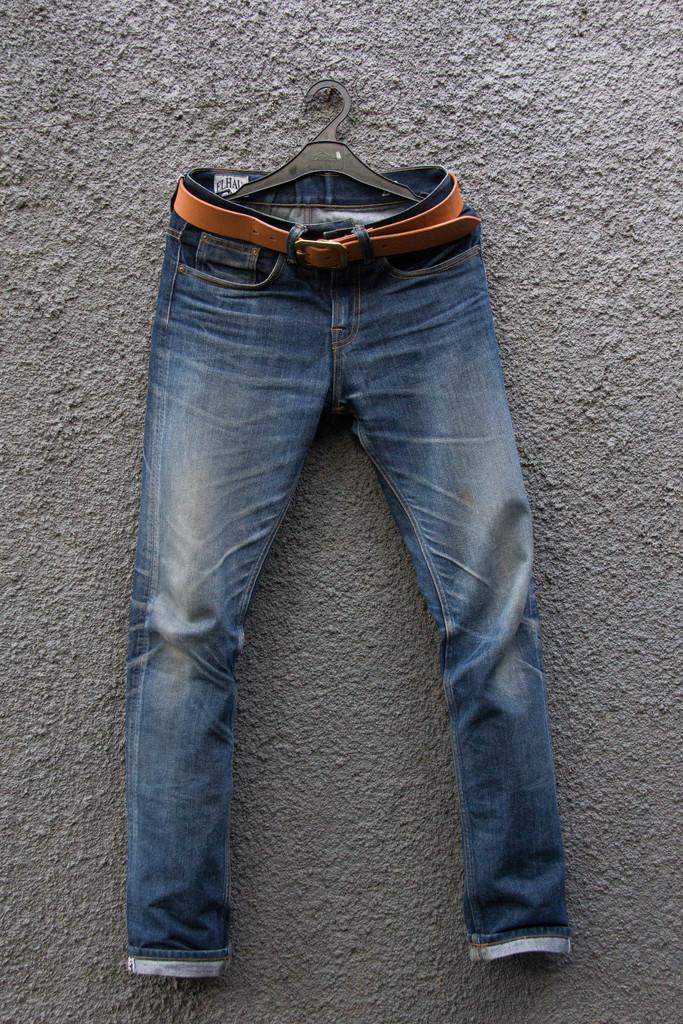Could you give a brief overview of what you see in this image? In this picture I can observe jeans pant in the middle of the picture. This jeans pant is hanging to the hanger. 